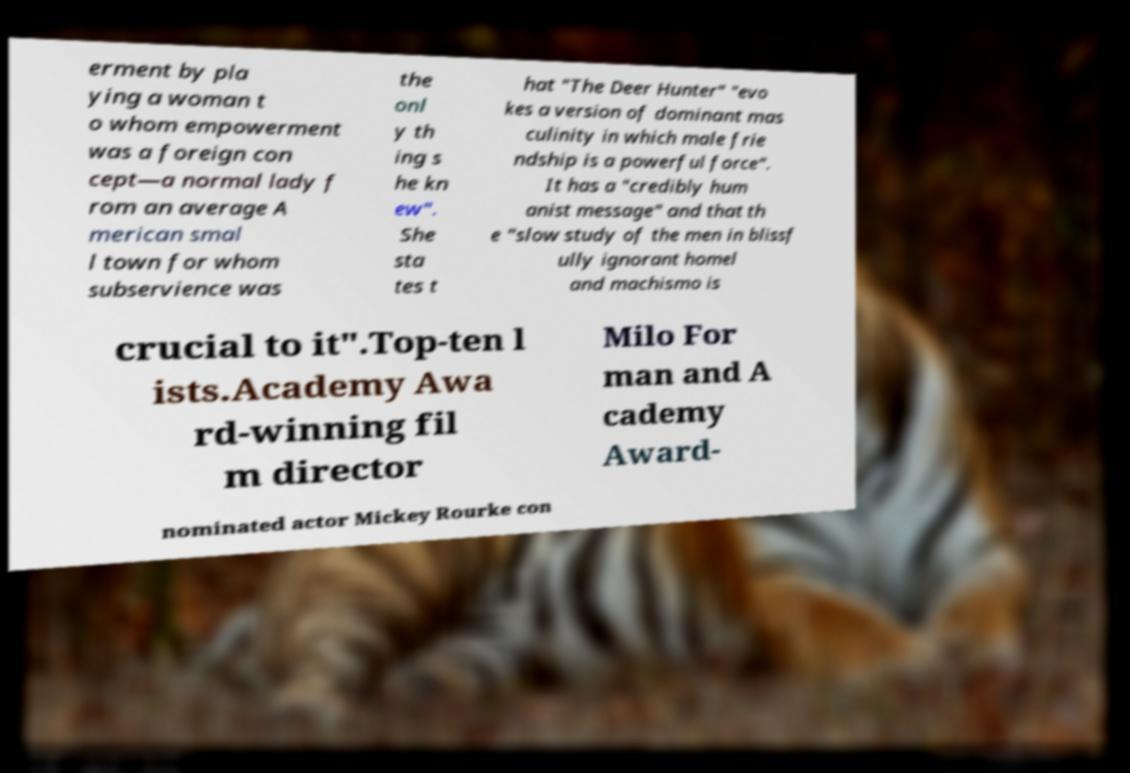Can you read and provide the text displayed in the image?This photo seems to have some interesting text. Can you extract and type it out for me? erment by pla ying a woman t o whom empowerment was a foreign con cept—a normal lady f rom an average A merican smal l town for whom subservience was the onl y th ing s he kn ew". She sta tes t hat "The Deer Hunter" "evo kes a version of dominant mas culinity in which male frie ndship is a powerful force". It has a "credibly hum anist message" and that th e "slow study of the men in blissf ully ignorant homel and machismo is crucial to it".Top-ten l ists.Academy Awa rd-winning fil m director Milo For man and A cademy Award- nominated actor Mickey Rourke con 